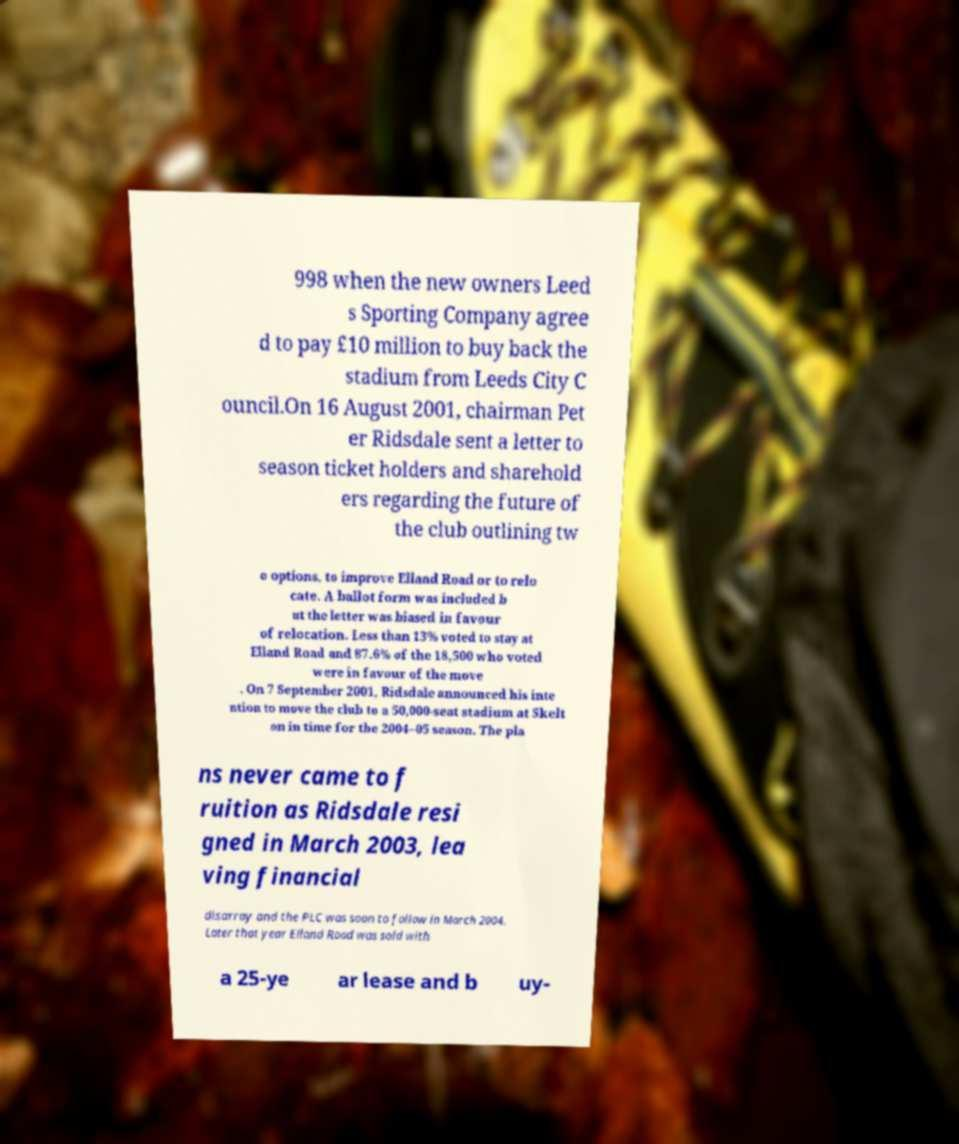Please read and relay the text visible in this image. What does it say? 998 when the new owners Leed s Sporting Company agree d to pay £10 million to buy back the stadium from Leeds City C ouncil.On 16 August 2001, chairman Pet er Ridsdale sent a letter to season ticket holders and sharehold ers regarding the future of the club outlining tw o options, to improve Elland Road or to relo cate. A ballot form was included b ut the letter was biased in favour of relocation. Less than 13% voted to stay at Elland Road and 87.6% of the 18,500 who voted were in favour of the move . On 7 September 2001, Ridsdale announced his inte ntion to move the club to a 50,000-seat stadium at Skelt on in time for the 2004–05 season. The pla ns never came to f ruition as Ridsdale resi gned in March 2003, lea ving financial disarray and the PLC was soon to follow in March 2004. Later that year Elland Road was sold with a 25-ye ar lease and b uy- 